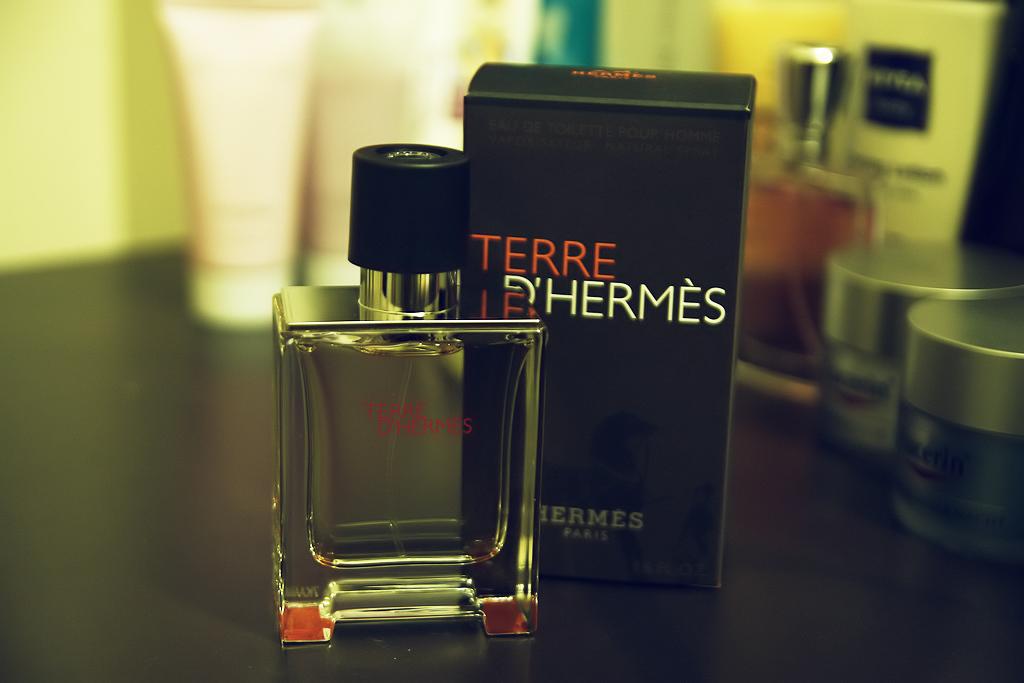What brand of cologne is this?
Give a very brief answer. Terre d'hermes. What city is shown on the box?
Your response must be concise. Paris. 